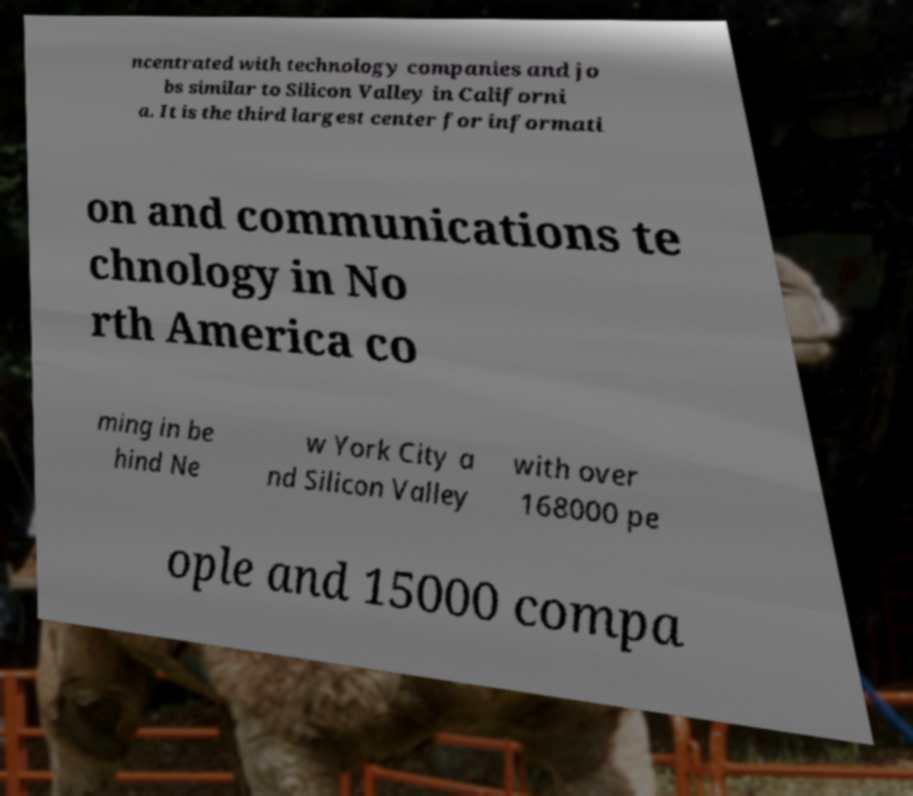Could you extract and type out the text from this image? ncentrated with technology companies and jo bs similar to Silicon Valley in Californi a. It is the third largest center for informati on and communications te chnology in No rth America co ming in be hind Ne w York City a nd Silicon Valley with over 168000 pe ople and 15000 compa 